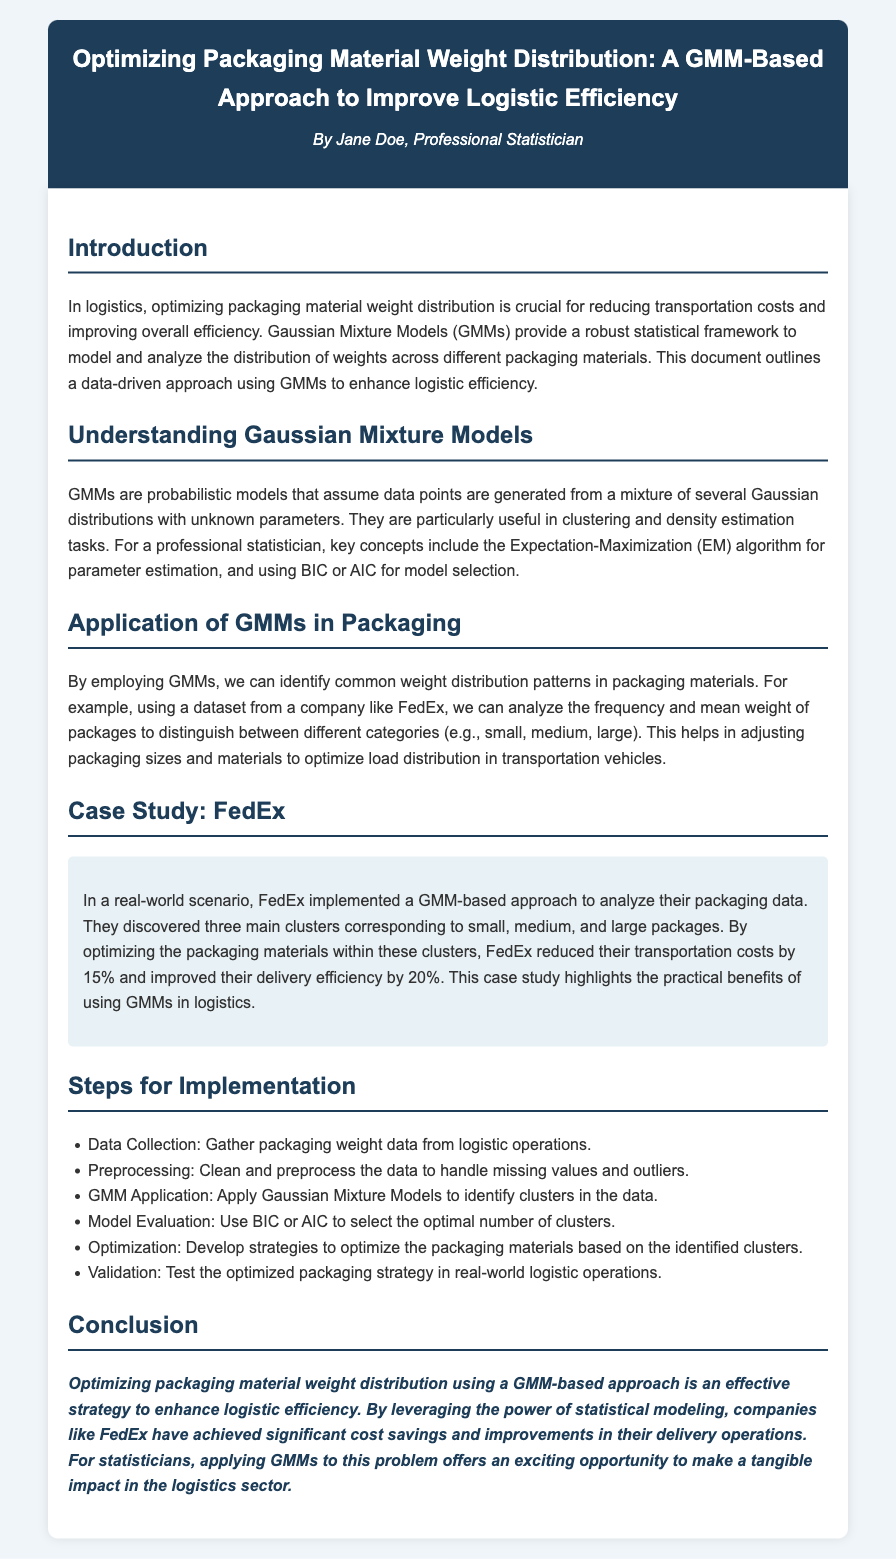What is the title of the document? The title is presented in the header section of the document, clearly indicating the main focus of the content.
Answer: Optimizing Packaging Material Weight Distribution: A GMM-Based Approach to Improve Logistic Efficiency Who is the author of the document? The author is credited in the header section, providing information about the individual behind the content.
Answer: Jane Doe What percentage of transportation cost reduction did FedEx achieve? This figure is mentioned in the case study section, highlighting the impact of implementing the GMM-based approach.
Answer: 15% What are the two statistical criteria mentioned for model selection? These criteria are outlined in the section describing GMMs, focusing on how to evaluate model performance.
Answer: BIC or AIC What is the first step in the implementation process? This step is listed in the "Steps for Implementation" section and represents the initial action to take when applying the GMM approach.
Answer: Data Collection How many main clusters did FedEx identify in their packaging data? This information is presented in the case study section, summarizing the results of their analysis with GMMs.
Answer: Three What was the improvement in delivery efficiency achieved by FedEx? This improvement is noted in the case study, indicating the effectiveness of the GMM-based optimization.
Answer: 20% What statistical method is utilized for parameter estimation in GMMs? This method is explained in the section on GMMs and is central to the functioning of this modeling approach.
Answer: Expectation-Maximization (EM) What type of models do GMMs represent? The document describes this within the relevant section, giving insight into the nature of GMMs.
Answer: Probabilistic models 